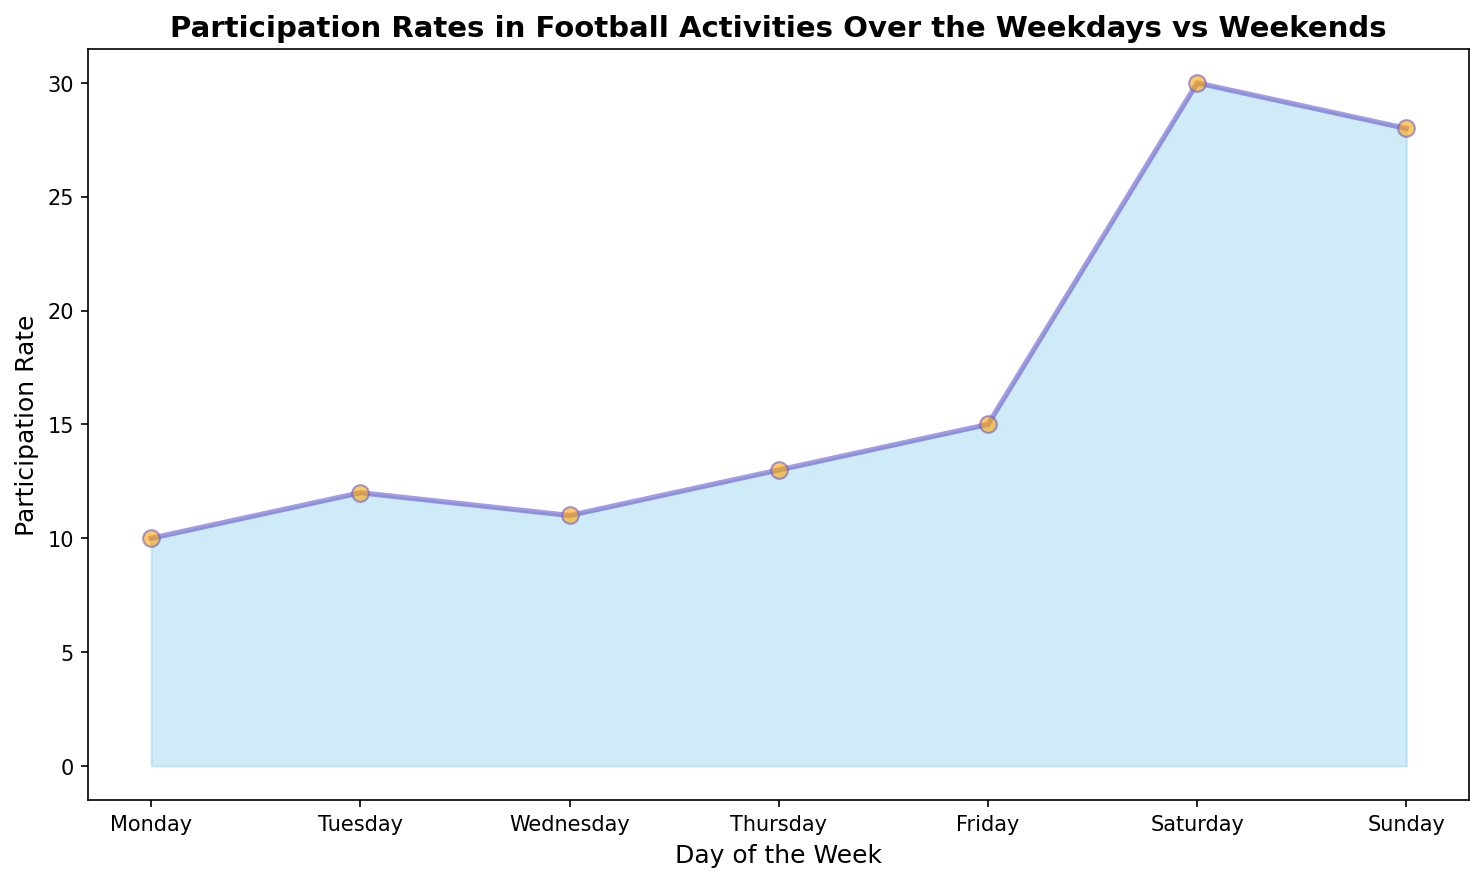What is the participation rate on Friday? Look for the height of the area corresponding to Friday on the x-axis, which should be at 15.
Answer: 15 Which day has the highest participation rate? Scan the plot visually and identify the peak of the filled area, which reaches its maximum height on Saturday.
Answer: Saturday What is the total participation rate for the weekdays (Monday to Friday)? Sum the participation rates from Monday to Friday: 10 + 12 + 11 + 13 + 15 = 61.
Answer: 61 What is the average participation rate on weekends (Saturday and Sunday)? Calculate the average of the participation rates for Saturday and Sunday: (30 + 28)/2 = 29.
Answer: 29 How does the participation rate on Thursday compare to Wednesday? Compare the height of the area on Thursday to Wednesday, with Thursday being higher at 13 vs 11 on Wednesday.
Answer: Thursday is higher Which day has the second lowest participation rate? By examining the heights of the filled area, the second lowest after Monday (10) is Wednesday (11).
Answer: Wednesday What is the difference in participation rates between Saturday and Tuesday? Subtract the participation rate of Tuesday from Saturday: 30 - 12 = 18.
Answer: 18 Is the participation rate on Sunday greater than the combined participation rates of Monday and Tuesday? Compare 28 (Sunday) to the sum of Monday and Tuesday: 28 > (10 + 12) = 22, so yes.
Answer: Yes What is the range of participation rates across the week? Find the minimum and maximum participation rates: Max is 30 (Saturday), Min is 10 (Monday), so range = 30 - 10 = 20.
Answer: 20 Describe the change in participation rates from Thursday to Friday. Observe the area height and see that it increases from 13 on Thursday to 15 on Friday.
Answer: Increases 